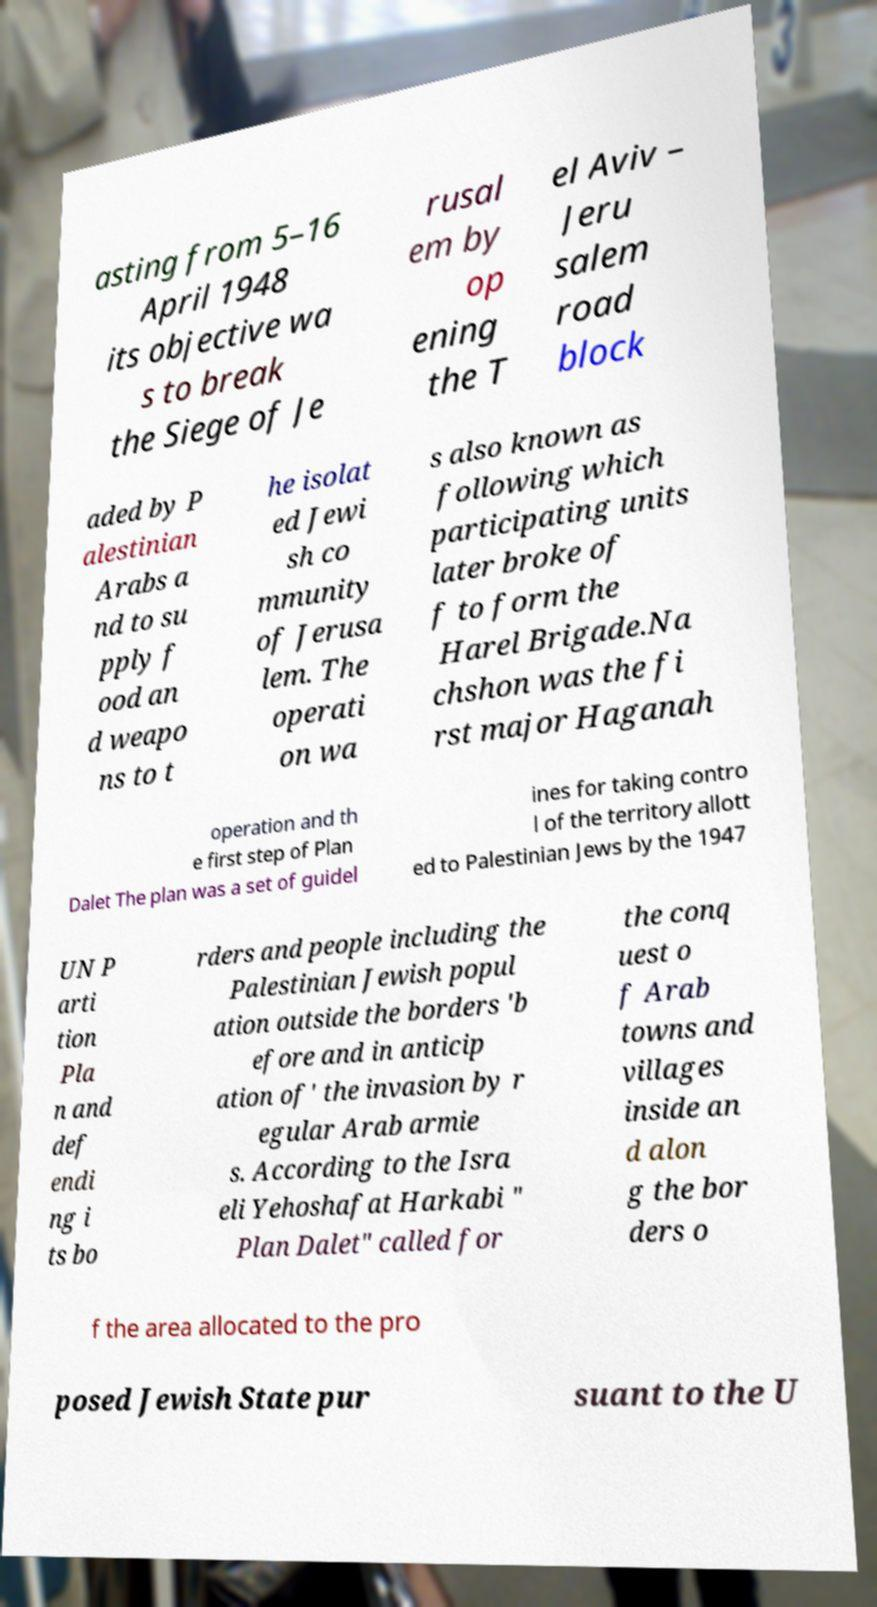Please read and relay the text visible in this image. What does it say? asting from 5–16 April 1948 its objective wa s to break the Siege of Je rusal em by op ening the T el Aviv – Jeru salem road block aded by P alestinian Arabs a nd to su pply f ood an d weapo ns to t he isolat ed Jewi sh co mmunity of Jerusa lem. The operati on wa s also known as following which participating units later broke of f to form the Harel Brigade.Na chshon was the fi rst major Haganah operation and th e first step of Plan Dalet The plan was a set of guidel ines for taking contro l of the territory allott ed to Palestinian Jews by the 1947 UN P arti tion Pla n and def endi ng i ts bo rders and people including the Palestinian Jewish popul ation outside the borders 'b efore and in anticip ation of' the invasion by r egular Arab armie s. According to the Isra eli Yehoshafat Harkabi " Plan Dalet" called for the conq uest o f Arab towns and villages inside an d alon g the bor ders o f the area allocated to the pro posed Jewish State pur suant to the U 